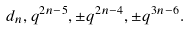Convert formula to latex. <formula><loc_0><loc_0><loc_500><loc_500>d _ { n } , q ^ { 2 n - 5 } , \pm q ^ { 2 n - 4 } , \pm q ^ { 3 n - 6 } .</formula> 